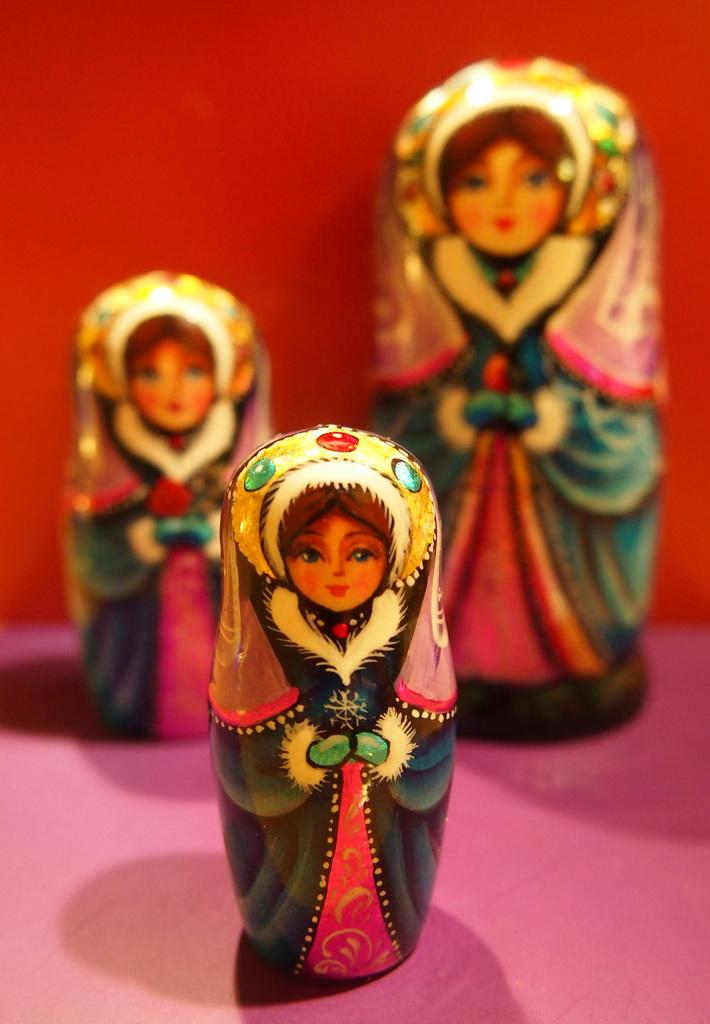What type of objects can be seen in the picture? There are dolls in the picture. What is the color of the surface on which the dolls are placed? The dolls are on a pink surface. Can you describe the background of the image? The background of the image is not clear. What type of kite is being flown in the background of the image? There is no kite present in the image; the background is not clear. Is there any blood visible on the dolls in the image? There is no blood visible on the dolls in the image. 